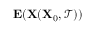<formula> <loc_0><loc_0><loc_500><loc_500>E ( X ( X _ { 0 } , \mathcal { T } ) )</formula> 